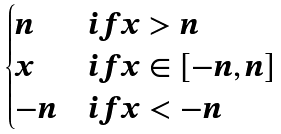<formula> <loc_0><loc_0><loc_500><loc_500>\begin{cases} n & i f x > n \\ x & i f x \in [ - n , n ] \\ - n & i f x < - n \end{cases}</formula> 